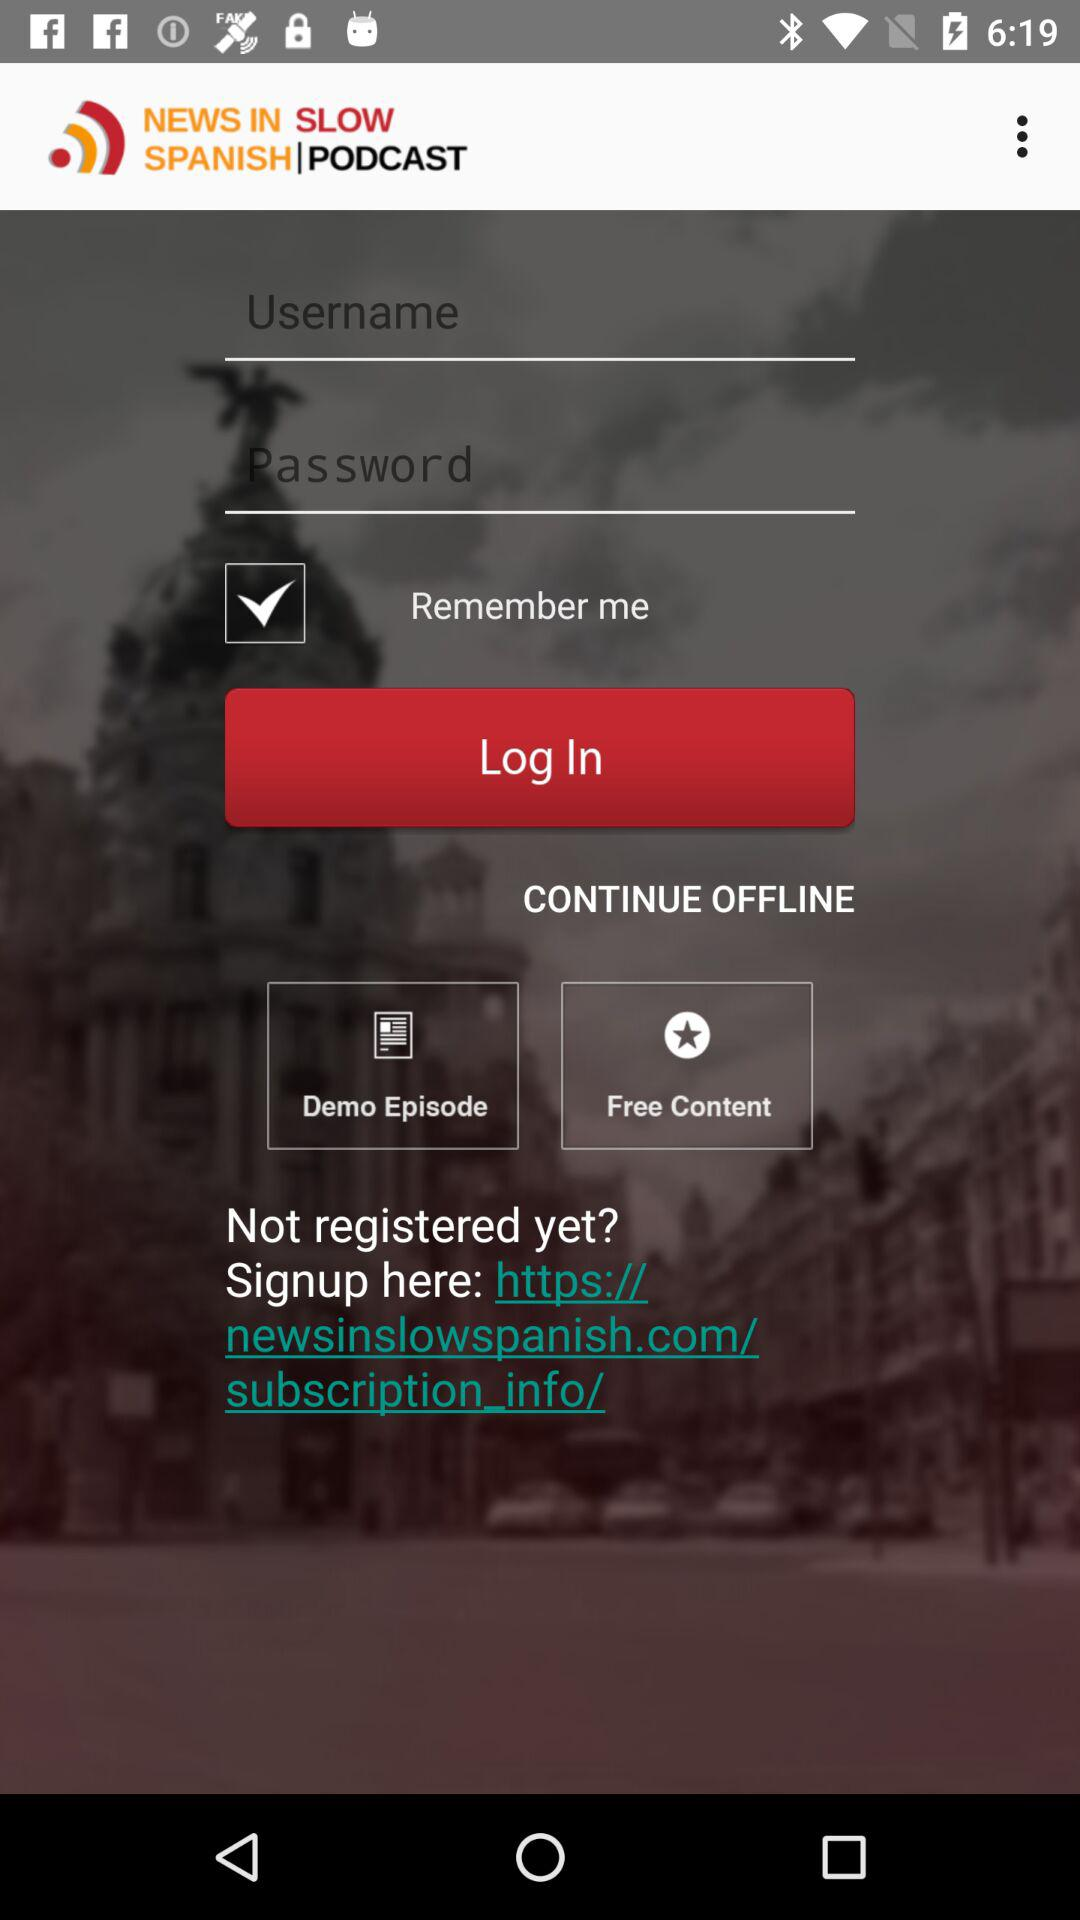What is the status of "Remember me"? The status is on. 